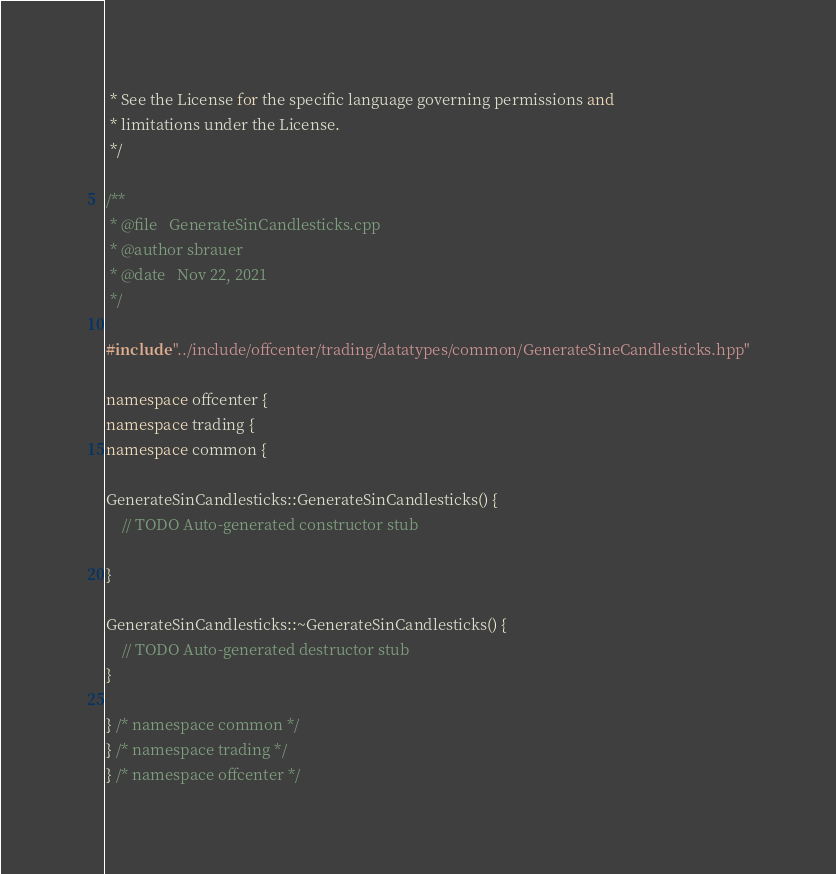Convert code to text. <code><loc_0><loc_0><loc_500><loc_500><_C++_> * See the License for the specific language governing permissions and
 * limitations under the License.
 */

/**
 * @file   GenerateSinCandlesticks.cpp
 * @author sbrauer
 * @date   Nov 22, 2021
 */

#include "../include/offcenter/trading/datatypes/common/GenerateSineCandlesticks.hpp"

namespace offcenter {
namespace trading {
namespace common {

GenerateSinCandlesticks::GenerateSinCandlesticks() {
	// TODO Auto-generated constructor stub

}

GenerateSinCandlesticks::~GenerateSinCandlesticks() {
	// TODO Auto-generated destructor stub
}

} /* namespace common */
} /* namespace trading */
} /* namespace offcenter */
</code> 